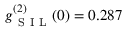Convert formula to latex. <formula><loc_0><loc_0><loc_500><loc_500>g _ { S I L } ^ { ( 2 ) } ( 0 ) = 0 . 2 8 7</formula> 